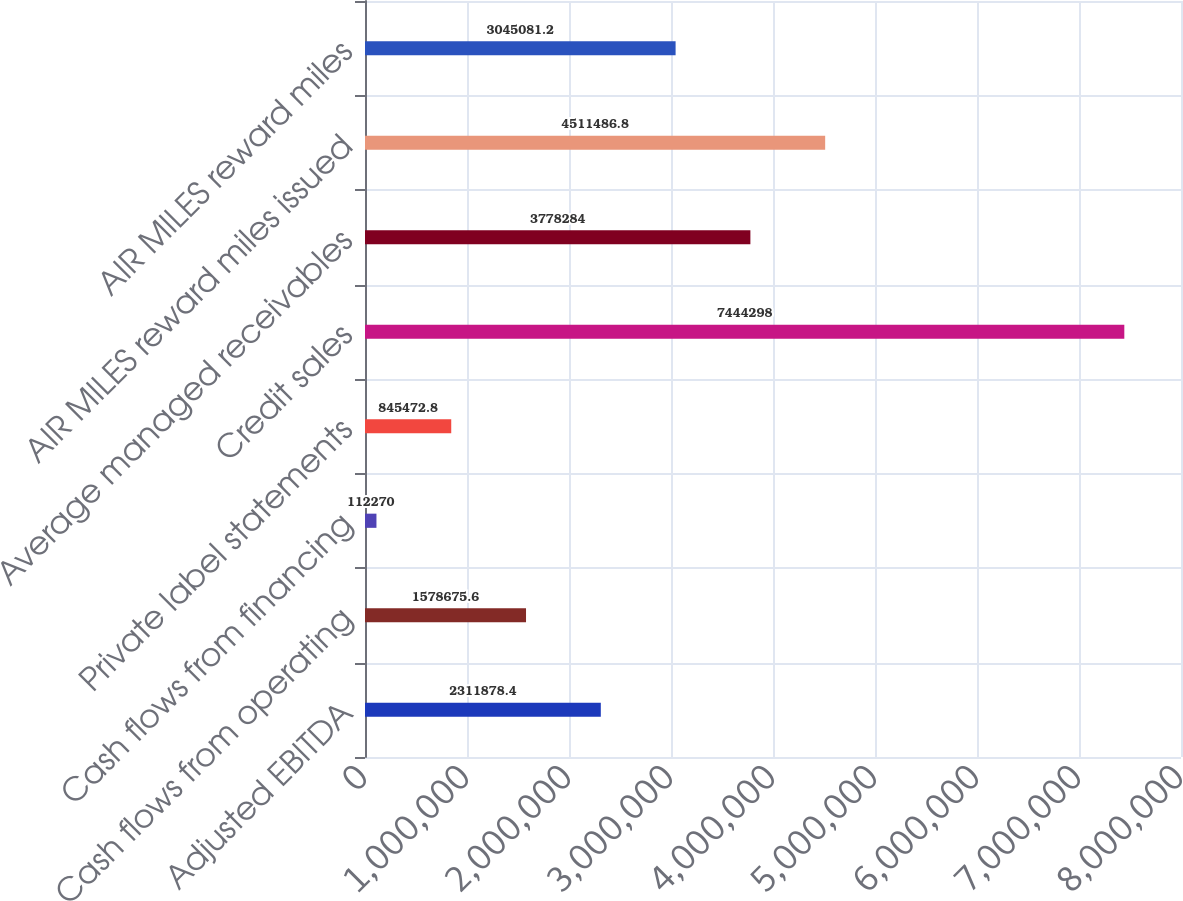Convert chart. <chart><loc_0><loc_0><loc_500><loc_500><bar_chart><fcel>Adjusted EBITDA<fcel>Cash flows from operating<fcel>Cash flows from financing<fcel>Private label statements<fcel>Credit sales<fcel>Average managed receivables<fcel>AIR MILES reward miles issued<fcel>AIR MILES reward miles<nl><fcel>2.31188e+06<fcel>1.57868e+06<fcel>112270<fcel>845473<fcel>7.4443e+06<fcel>3.77828e+06<fcel>4.51149e+06<fcel>3.04508e+06<nl></chart> 